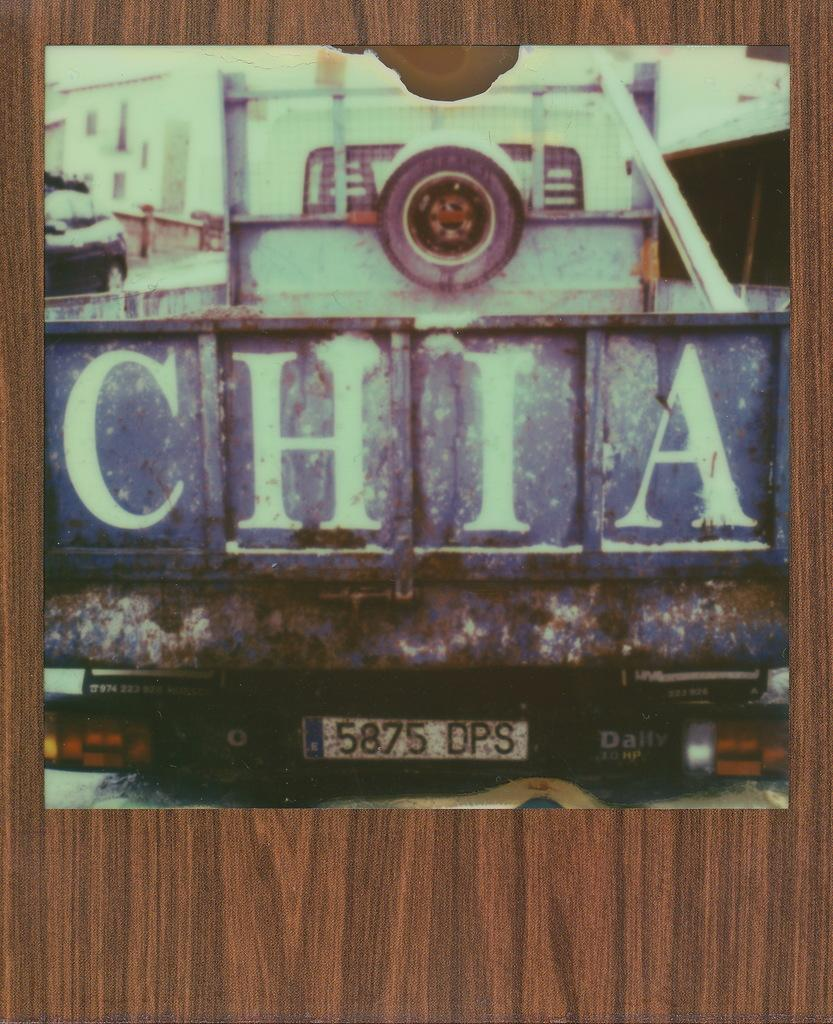What type of structure is present in the image? There is a wooden frame in the image. What is the main subject in the center of the image? There is a vehicle in the center of the image. What feature is present on the vehicle? The vehicle has a number board. What additional information is associated with the vehicle? There is text associated with the vehicle. Can you tell me how many goats are standing near the vehicle in the image? There are no goats present in the image. What is the interest rate of the loan associated with the vehicle in the image? There is no information about a loan or interest rate in the image. 